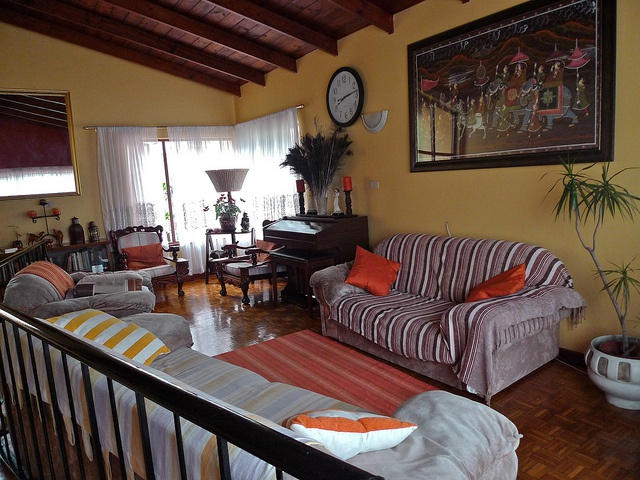Describe the objects in this image and their specific colors. I can see couch in black, gray, and maroon tones, couch in black, darkgray, gray, and lightblue tones, potted plant in black, olive, and gray tones, chair in black, gray, and brown tones, and couch in black, gray, maroon, and brown tones in this image. 